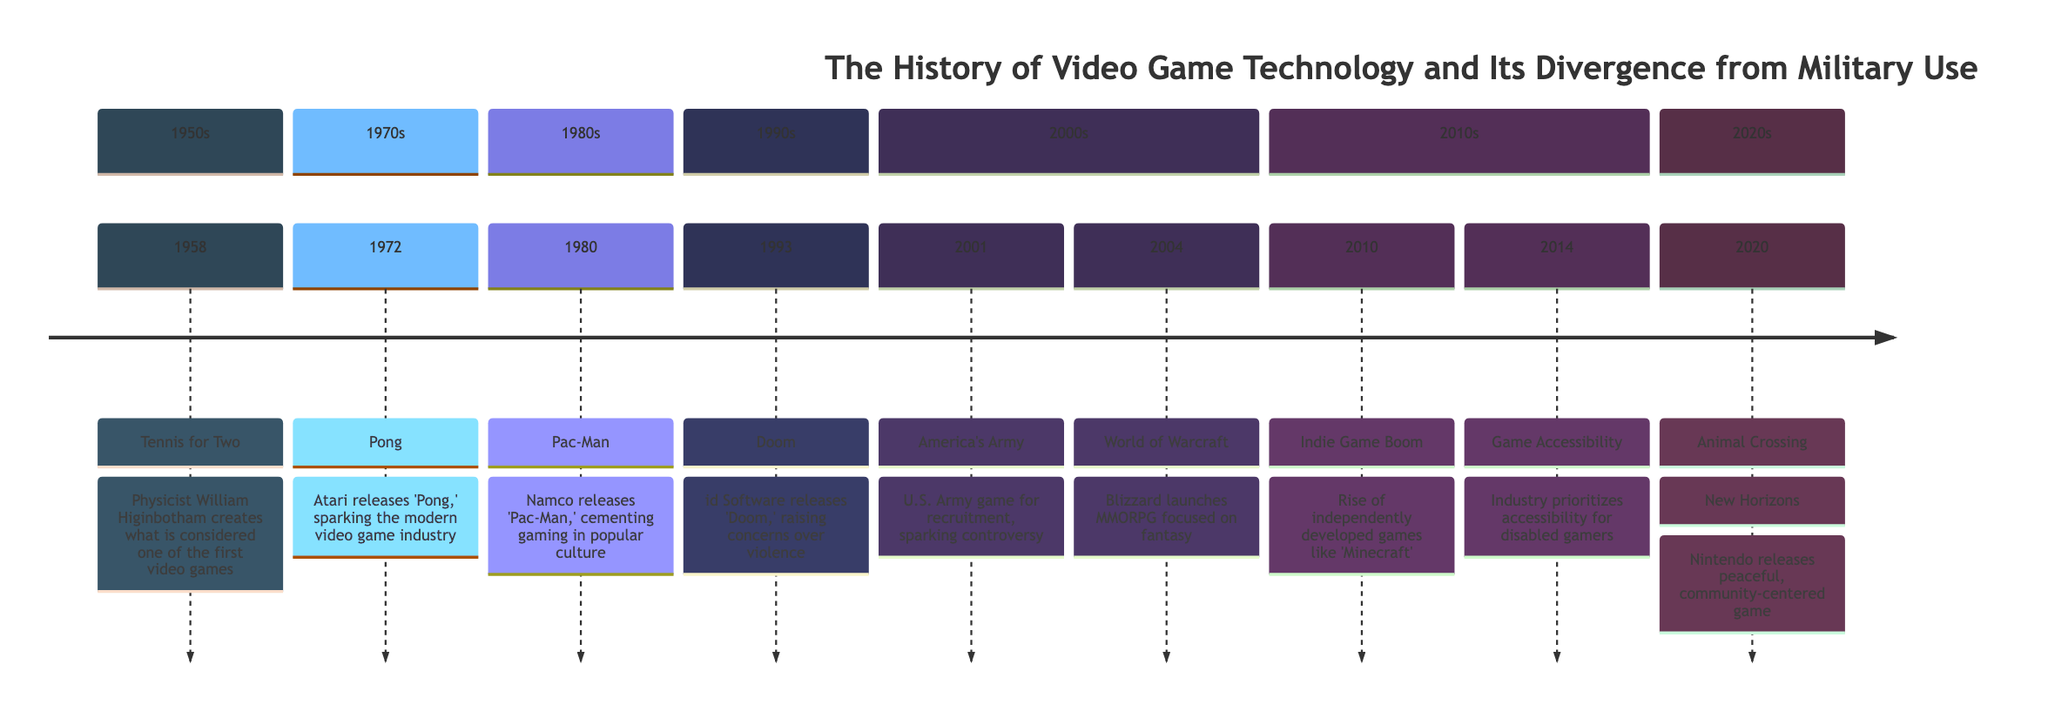What is the first event in the timeline? The first event listed in the timeline is "Tennis for Two," which occurred in 1958. This can be identified by looking at the earliest year mentioned in the timeline.
Answer: Tennis for Two Which year did 'Pac-Man' release? The timeline specifies that 'Pac-Man' was released in 1980, as it is associated with that year in the 1980s section of the timeline.
Answer: 1980 How many events are listed in the 2000s? In the 2000s section, there are two events: 'America's Army' in 2001 and 'World of Warcraft' in 2004. Counting these gives the total.
Answer: 2 What significant shift in focus does 'World of Warcraft' represent? 'World of Warcraft' represents a shift away from military use towards fantasy and community, highlighting entertainment aspects of gaming. This is seen in its description, which contrasts it to 'America's Army.'
Answer: Fantasy and community In what year did the video game technology diverge from military use? The tension between military use and recreational gaming is notably highlighted between the introduction of 'America's Army' in 2001 and significant titles like 'World of Warcraft' in 2004. This indicates a shift that can be pinpointed in 2004.
Answer: 2004 What is the last event in the timeline? The last event recorded in the timeline is 'Animal Crossing: New Horizons,' which happened in 2020. This can be confirmed by finding the last year listed in the timeline.
Answer: Animal Crossing: New Horizons Which event raised concerns over violence? The event that raised concerns over violence is the release of 'Doom' in 1993. It is explicitly stated in the timeline's description of this event.
Answer: Doom What year did the Indie Game Boom occur? The Indie Game Boom is noted to have occurred in 2010, as indicated in the 2010s section of the timeline.
Answer: 2010 